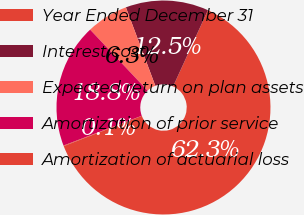Convert chart. <chart><loc_0><loc_0><loc_500><loc_500><pie_chart><fcel>Year Ended December 31<fcel>Interest cost<fcel>Expected return on plan assets<fcel>Amortization of prior service<fcel>Amortization of actuarial loss<nl><fcel>62.3%<fcel>12.53%<fcel>6.31%<fcel>18.76%<fcel>0.09%<nl></chart> 